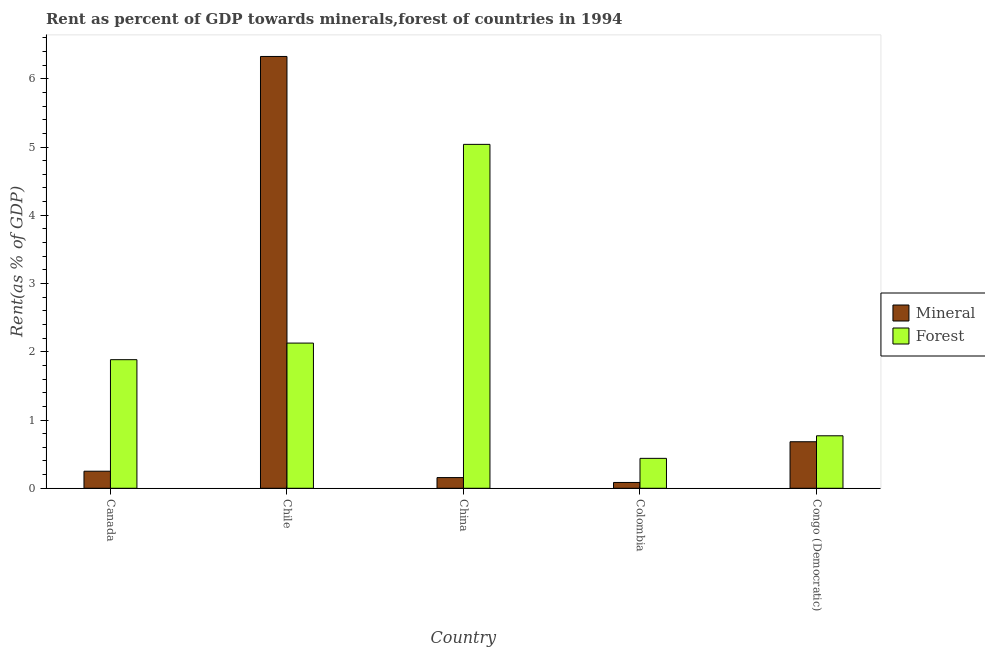How many groups of bars are there?
Provide a short and direct response. 5. Are the number of bars per tick equal to the number of legend labels?
Provide a succinct answer. Yes. Are the number of bars on each tick of the X-axis equal?
Offer a terse response. Yes. How many bars are there on the 3rd tick from the right?
Keep it short and to the point. 2. What is the label of the 4th group of bars from the left?
Make the answer very short. Colombia. In how many cases, is the number of bars for a given country not equal to the number of legend labels?
Keep it short and to the point. 0. What is the forest rent in Colombia?
Provide a short and direct response. 0.44. Across all countries, what is the maximum forest rent?
Provide a short and direct response. 5.04. Across all countries, what is the minimum forest rent?
Provide a short and direct response. 0.44. In which country was the forest rent minimum?
Provide a short and direct response. Colombia. What is the total mineral rent in the graph?
Provide a succinct answer. 7.5. What is the difference between the mineral rent in Canada and that in Congo (Democratic)?
Ensure brevity in your answer.  -0.43. What is the difference between the mineral rent in Canada and the forest rent in Chile?
Provide a succinct answer. -1.88. What is the average forest rent per country?
Offer a terse response. 2.05. What is the difference between the forest rent and mineral rent in Canada?
Your answer should be compact. 1.63. In how many countries, is the mineral rent greater than 2 %?
Offer a very short reply. 1. What is the ratio of the forest rent in Canada to that in Colombia?
Your response must be concise. 4.3. What is the difference between the highest and the second highest mineral rent?
Provide a succinct answer. 5.64. What is the difference between the highest and the lowest forest rent?
Ensure brevity in your answer.  4.6. In how many countries, is the forest rent greater than the average forest rent taken over all countries?
Offer a terse response. 2. What does the 1st bar from the left in Colombia represents?
Give a very brief answer. Mineral. What does the 2nd bar from the right in Canada represents?
Ensure brevity in your answer.  Mineral. Are all the bars in the graph horizontal?
Your response must be concise. No. How many countries are there in the graph?
Ensure brevity in your answer.  5. What is the difference between two consecutive major ticks on the Y-axis?
Offer a very short reply. 1. Where does the legend appear in the graph?
Your response must be concise. Center right. How are the legend labels stacked?
Your answer should be compact. Vertical. What is the title of the graph?
Make the answer very short. Rent as percent of GDP towards minerals,forest of countries in 1994. Does "Fraud firms" appear as one of the legend labels in the graph?
Your answer should be very brief. No. What is the label or title of the X-axis?
Offer a terse response. Country. What is the label or title of the Y-axis?
Give a very brief answer. Rent(as % of GDP). What is the Rent(as % of GDP) in Mineral in Canada?
Give a very brief answer. 0.25. What is the Rent(as % of GDP) of Forest in Canada?
Provide a short and direct response. 1.88. What is the Rent(as % of GDP) in Mineral in Chile?
Provide a succinct answer. 6.33. What is the Rent(as % of GDP) of Forest in Chile?
Offer a very short reply. 2.13. What is the Rent(as % of GDP) in Mineral in China?
Give a very brief answer. 0.16. What is the Rent(as % of GDP) in Forest in China?
Your answer should be compact. 5.04. What is the Rent(as % of GDP) of Mineral in Colombia?
Provide a succinct answer. 0.09. What is the Rent(as % of GDP) in Forest in Colombia?
Provide a succinct answer. 0.44. What is the Rent(as % of GDP) of Mineral in Congo (Democratic)?
Offer a very short reply. 0.68. What is the Rent(as % of GDP) in Forest in Congo (Democratic)?
Your answer should be compact. 0.77. Across all countries, what is the maximum Rent(as % of GDP) in Mineral?
Make the answer very short. 6.33. Across all countries, what is the maximum Rent(as % of GDP) in Forest?
Offer a terse response. 5.04. Across all countries, what is the minimum Rent(as % of GDP) of Mineral?
Provide a short and direct response. 0.09. Across all countries, what is the minimum Rent(as % of GDP) of Forest?
Make the answer very short. 0.44. What is the total Rent(as % of GDP) in Mineral in the graph?
Your response must be concise. 7.5. What is the total Rent(as % of GDP) in Forest in the graph?
Your answer should be very brief. 10.26. What is the difference between the Rent(as % of GDP) of Mineral in Canada and that in Chile?
Your answer should be very brief. -6.08. What is the difference between the Rent(as % of GDP) in Forest in Canada and that in Chile?
Ensure brevity in your answer.  -0.24. What is the difference between the Rent(as % of GDP) in Mineral in Canada and that in China?
Give a very brief answer. 0.09. What is the difference between the Rent(as % of GDP) in Forest in Canada and that in China?
Offer a very short reply. -3.15. What is the difference between the Rent(as % of GDP) of Mineral in Canada and that in Colombia?
Offer a very short reply. 0.16. What is the difference between the Rent(as % of GDP) of Forest in Canada and that in Colombia?
Offer a very short reply. 1.45. What is the difference between the Rent(as % of GDP) of Mineral in Canada and that in Congo (Democratic)?
Make the answer very short. -0.43. What is the difference between the Rent(as % of GDP) of Forest in Canada and that in Congo (Democratic)?
Provide a succinct answer. 1.12. What is the difference between the Rent(as % of GDP) in Mineral in Chile and that in China?
Your answer should be compact. 6.17. What is the difference between the Rent(as % of GDP) in Forest in Chile and that in China?
Your response must be concise. -2.91. What is the difference between the Rent(as % of GDP) of Mineral in Chile and that in Colombia?
Offer a very short reply. 6.24. What is the difference between the Rent(as % of GDP) of Forest in Chile and that in Colombia?
Provide a short and direct response. 1.69. What is the difference between the Rent(as % of GDP) in Mineral in Chile and that in Congo (Democratic)?
Keep it short and to the point. 5.64. What is the difference between the Rent(as % of GDP) of Forest in Chile and that in Congo (Democratic)?
Offer a very short reply. 1.36. What is the difference between the Rent(as % of GDP) in Mineral in China and that in Colombia?
Your answer should be compact. 0.07. What is the difference between the Rent(as % of GDP) in Forest in China and that in Colombia?
Give a very brief answer. 4.6. What is the difference between the Rent(as % of GDP) of Mineral in China and that in Congo (Democratic)?
Keep it short and to the point. -0.53. What is the difference between the Rent(as % of GDP) of Forest in China and that in Congo (Democratic)?
Your response must be concise. 4.27. What is the difference between the Rent(as % of GDP) in Mineral in Colombia and that in Congo (Democratic)?
Your answer should be very brief. -0.6. What is the difference between the Rent(as % of GDP) of Forest in Colombia and that in Congo (Democratic)?
Your answer should be very brief. -0.33. What is the difference between the Rent(as % of GDP) in Mineral in Canada and the Rent(as % of GDP) in Forest in Chile?
Give a very brief answer. -1.88. What is the difference between the Rent(as % of GDP) in Mineral in Canada and the Rent(as % of GDP) in Forest in China?
Your answer should be very brief. -4.79. What is the difference between the Rent(as % of GDP) of Mineral in Canada and the Rent(as % of GDP) of Forest in Colombia?
Offer a terse response. -0.19. What is the difference between the Rent(as % of GDP) in Mineral in Canada and the Rent(as % of GDP) in Forest in Congo (Democratic)?
Ensure brevity in your answer.  -0.52. What is the difference between the Rent(as % of GDP) in Mineral in Chile and the Rent(as % of GDP) in Forest in China?
Offer a very short reply. 1.29. What is the difference between the Rent(as % of GDP) of Mineral in Chile and the Rent(as % of GDP) of Forest in Colombia?
Provide a short and direct response. 5.89. What is the difference between the Rent(as % of GDP) in Mineral in Chile and the Rent(as % of GDP) in Forest in Congo (Democratic)?
Offer a very short reply. 5.56. What is the difference between the Rent(as % of GDP) in Mineral in China and the Rent(as % of GDP) in Forest in Colombia?
Make the answer very short. -0.28. What is the difference between the Rent(as % of GDP) of Mineral in China and the Rent(as % of GDP) of Forest in Congo (Democratic)?
Your answer should be very brief. -0.61. What is the difference between the Rent(as % of GDP) in Mineral in Colombia and the Rent(as % of GDP) in Forest in Congo (Democratic)?
Make the answer very short. -0.68. What is the average Rent(as % of GDP) of Mineral per country?
Your response must be concise. 1.5. What is the average Rent(as % of GDP) in Forest per country?
Offer a very short reply. 2.05. What is the difference between the Rent(as % of GDP) in Mineral and Rent(as % of GDP) in Forest in Canada?
Offer a very short reply. -1.63. What is the difference between the Rent(as % of GDP) of Mineral and Rent(as % of GDP) of Forest in Chile?
Your response must be concise. 4.2. What is the difference between the Rent(as % of GDP) of Mineral and Rent(as % of GDP) of Forest in China?
Your answer should be very brief. -4.88. What is the difference between the Rent(as % of GDP) in Mineral and Rent(as % of GDP) in Forest in Colombia?
Give a very brief answer. -0.35. What is the difference between the Rent(as % of GDP) in Mineral and Rent(as % of GDP) in Forest in Congo (Democratic)?
Offer a very short reply. -0.09. What is the ratio of the Rent(as % of GDP) in Mineral in Canada to that in Chile?
Make the answer very short. 0.04. What is the ratio of the Rent(as % of GDP) in Forest in Canada to that in Chile?
Provide a succinct answer. 0.89. What is the ratio of the Rent(as % of GDP) of Mineral in Canada to that in China?
Offer a terse response. 1.6. What is the ratio of the Rent(as % of GDP) in Forest in Canada to that in China?
Make the answer very short. 0.37. What is the ratio of the Rent(as % of GDP) of Mineral in Canada to that in Colombia?
Your response must be concise. 2.93. What is the ratio of the Rent(as % of GDP) of Forest in Canada to that in Colombia?
Your answer should be compact. 4.3. What is the ratio of the Rent(as % of GDP) in Mineral in Canada to that in Congo (Democratic)?
Offer a terse response. 0.37. What is the ratio of the Rent(as % of GDP) of Forest in Canada to that in Congo (Democratic)?
Provide a short and direct response. 2.45. What is the ratio of the Rent(as % of GDP) of Mineral in Chile to that in China?
Offer a very short reply. 40.37. What is the ratio of the Rent(as % of GDP) of Forest in Chile to that in China?
Your answer should be compact. 0.42. What is the ratio of the Rent(as % of GDP) in Mineral in Chile to that in Colombia?
Ensure brevity in your answer.  74.11. What is the ratio of the Rent(as % of GDP) of Forest in Chile to that in Colombia?
Make the answer very short. 4.85. What is the ratio of the Rent(as % of GDP) of Mineral in Chile to that in Congo (Democratic)?
Ensure brevity in your answer.  9.28. What is the ratio of the Rent(as % of GDP) in Forest in Chile to that in Congo (Democratic)?
Offer a terse response. 2.77. What is the ratio of the Rent(as % of GDP) in Mineral in China to that in Colombia?
Keep it short and to the point. 1.84. What is the ratio of the Rent(as % of GDP) of Forest in China to that in Colombia?
Your response must be concise. 11.49. What is the ratio of the Rent(as % of GDP) of Mineral in China to that in Congo (Democratic)?
Offer a terse response. 0.23. What is the ratio of the Rent(as % of GDP) in Forest in China to that in Congo (Democratic)?
Your answer should be compact. 6.55. What is the ratio of the Rent(as % of GDP) of Mineral in Colombia to that in Congo (Democratic)?
Provide a short and direct response. 0.13. What is the ratio of the Rent(as % of GDP) of Forest in Colombia to that in Congo (Democratic)?
Offer a terse response. 0.57. What is the difference between the highest and the second highest Rent(as % of GDP) in Mineral?
Give a very brief answer. 5.64. What is the difference between the highest and the second highest Rent(as % of GDP) in Forest?
Make the answer very short. 2.91. What is the difference between the highest and the lowest Rent(as % of GDP) of Mineral?
Ensure brevity in your answer.  6.24. What is the difference between the highest and the lowest Rent(as % of GDP) of Forest?
Provide a short and direct response. 4.6. 